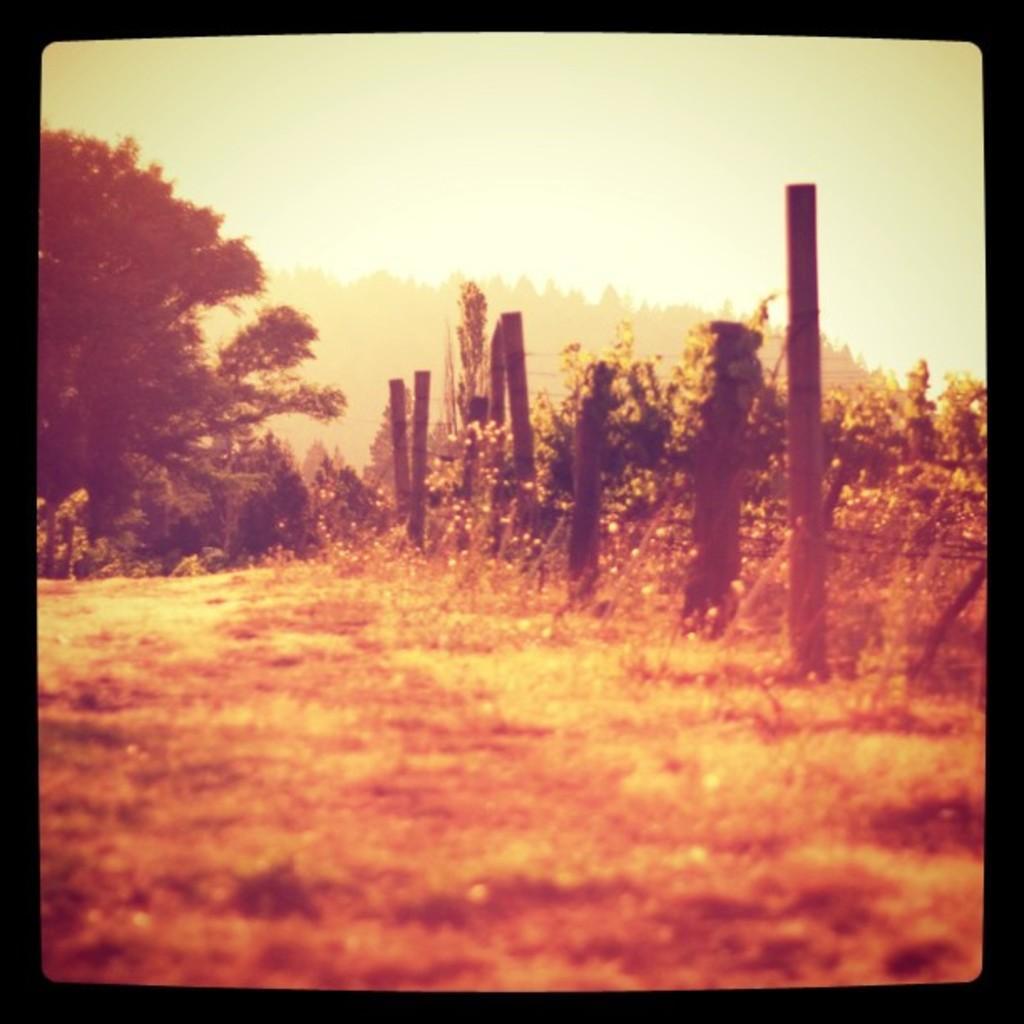Please provide a concise description of this image. At the bottom of the image on the ground there is grass. There are fencing poles. Behind the poles there are plants. In the background there are trees. There is a black border to the image. 